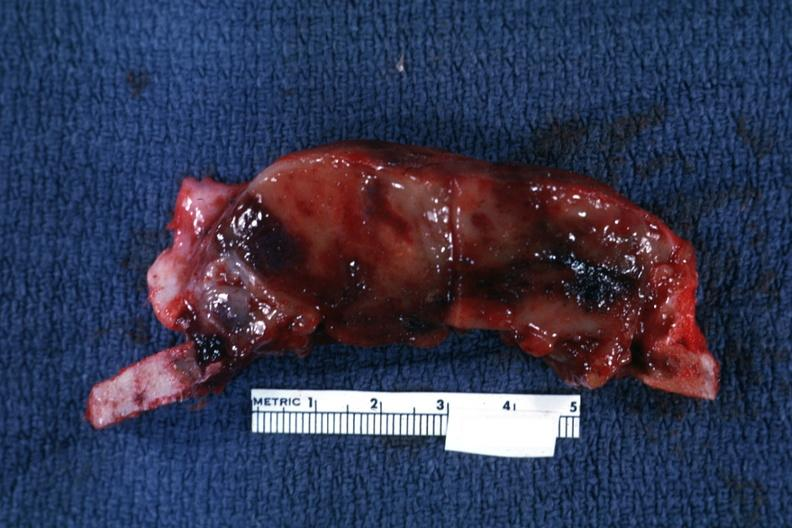what is present?
Answer the question using a single word or phrase. Joints 